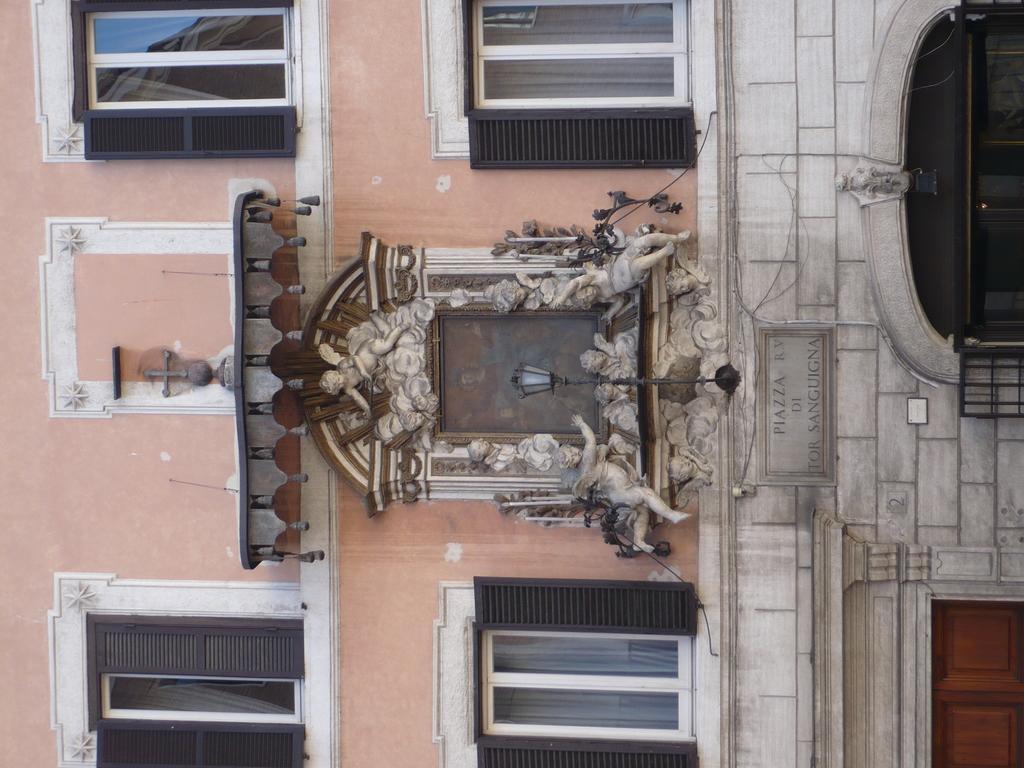Could you give a brief overview of what you see in this image? In this image there is a building in the vertical direction. To the building there are four windows and a light in the center. 